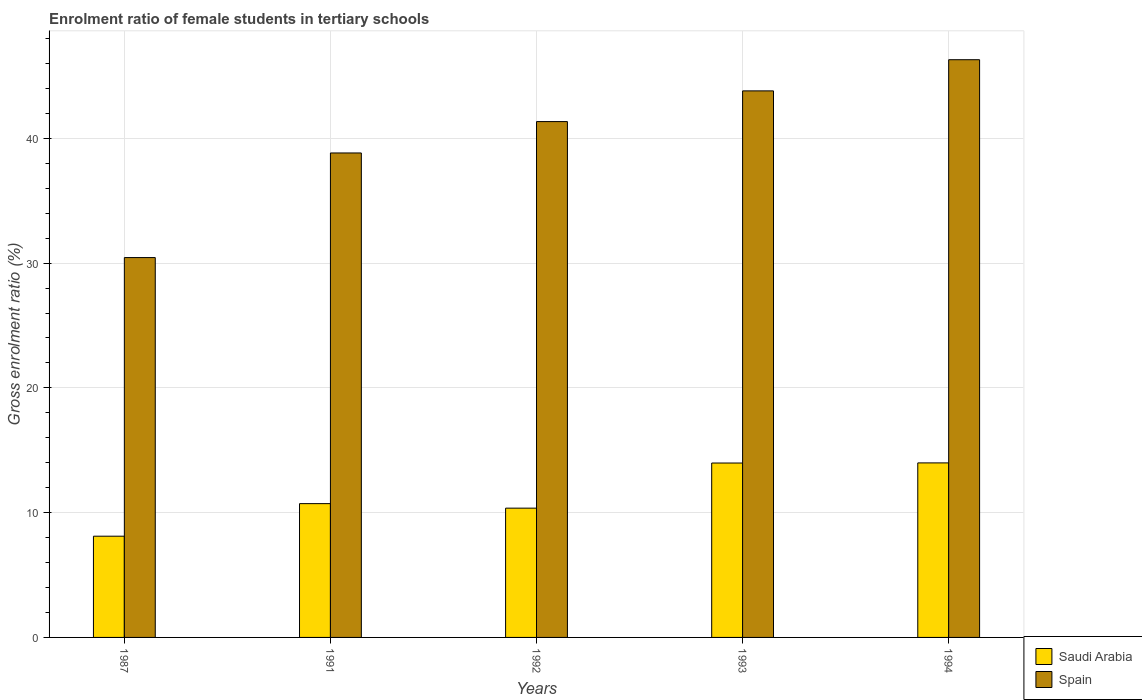How many different coloured bars are there?
Offer a very short reply. 2. How many groups of bars are there?
Give a very brief answer. 5. How many bars are there on the 1st tick from the right?
Your answer should be compact. 2. What is the label of the 3rd group of bars from the left?
Offer a terse response. 1992. In how many cases, is the number of bars for a given year not equal to the number of legend labels?
Your response must be concise. 0. What is the enrolment ratio of female students in tertiary schools in Spain in 1993?
Your answer should be compact. 43.8. Across all years, what is the maximum enrolment ratio of female students in tertiary schools in Spain?
Your response must be concise. 46.3. Across all years, what is the minimum enrolment ratio of female students in tertiary schools in Saudi Arabia?
Your response must be concise. 8.11. In which year was the enrolment ratio of female students in tertiary schools in Spain maximum?
Your answer should be very brief. 1994. What is the total enrolment ratio of female students in tertiary schools in Spain in the graph?
Give a very brief answer. 200.71. What is the difference between the enrolment ratio of female students in tertiary schools in Saudi Arabia in 1992 and that in 1993?
Offer a terse response. -3.62. What is the difference between the enrolment ratio of female students in tertiary schools in Spain in 1991 and the enrolment ratio of female students in tertiary schools in Saudi Arabia in 1994?
Provide a short and direct response. 24.84. What is the average enrolment ratio of female students in tertiary schools in Spain per year?
Keep it short and to the point. 40.14. In the year 1993, what is the difference between the enrolment ratio of female students in tertiary schools in Spain and enrolment ratio of female students in tertiary schools in Saudi Arabia?
Your answer should be compact. 29.83. In how many years, is the enrolment ratio of female students in tertiary schools in Saudi Arabia greater than 28 %?
Make the answer very short. 0. What is the ratio of the enrolment ratio of female students in tertiary schools in Saudi Arabia in 1987 to that in 1994?
Your response must be concise. 0.58. Is the difference between the enrolment ratio of female students in tertiary schools in Spain in 1993 and 1994 greater than the difference between the enrolment ratio of female students in tertiary schools in Saudi Arabia in 1993 and 1994?
Make the answer very short. No. What is the difference between the highest and the second highest enrolment ratio of female students in tertiary schools in Saudi Arabia?
Your answer should be very brief. 0.01. What is the difference between the highest and the lowest enrolment ratio of female students in tertiary schools in Spain?
Ensure brevity in your answer.  15.86. In how many years, is the enrolment ratio of female students in tertiary schools in Saudi Arabia greater than the average enrolment ratio of female students in tertiary schools in Saudi Arabia taken over all years?
Offer a terse response. 2. Is the sum of the enrolment ratio of female students in tertiary schools in Saudi Arabia in 1987 and 1994 greater than the maximum enrolment ratio of female students in tertiary schools in Spain across all years?
Your answer should be compact. No. What does the 1st bar from the left in 1992 represents?
Make the answer very short. Saudi Arabia. What does the 2nd bar from the right in 1994 represents?
Your response must be concise. Saudi Arabia. How many years are there in the graph?
Your answer should be very brief. 5. What is the difference between two consecutive major ticks on the Y-axis?
Give a very brief answer. 10. Are the values on the major ticks of Y-axis written in scientific E-notation?
Provide a short and direct response. No. What is the title of the graph?
Your response must be concise. Enrolment ratio of female students in tertiary schools. What is the label or title of the Y-axis?
Keep it short and to the point. Gross enrolment ratio (%). What is the Gross enrolment ratio (%) of Saudi Arabia in 1987?
Offer a very short reply. 8.11. What is the Gross enrolment ratio (%) in Spain in 1987?
Provide a succinct answer. 30.44. What is the Gross enrolment ratio (%) of Saudi Arabia in 1991?
Offer a terse response. 10.72. What is the Gross enrolment ratio (%) in Spain in 1991?
Provide a succinct answer. 38.83. What is the Gross enrolment ratio (%) of Saudi Arabia in 1992?
Keep it short and to the point. 10.36. What is the Gross enrolment ratio (%) in Spain in 1992?
Your response must be concise. 41.34. What is the Gross enrolment ratio (%) in Saudi Arabia in 1993?
Keep it short and to the point. 13.98. What is the Gross enrolment ratio (%) in Spain in 1993?
Offer a terse response. 43.8. What is the Gross enrolment ratio (%) in Saudi Arabia in 1994?
Your response must be concise. 13.99. What is the Gross enrolment ratio (%) of Spain in 1994?
Your answer should be compact. 46.3. Across all years, what is the maximum Gross enrolment ratio (%) in Saudi Arabia?
Your answer should be very brief. 13.99. Across all years, what is the maximum Gross enrolment ratio (%) in Spain?
Offer a very short reply. 46.3. Across all years, what is the minimum Gross enrolment ratio (%) of Saudi Arabia?
Your answer should be compact. 8.11. Across all years, what is the minimum Gross enrolment ratio (%) of Spain?
Your answer should be compact. 30.44. What is the total Gross enrolment ratio (%) of Saudi Arabia in the graph?
Your answer should be very brief. 57.16. What is the total Gross enrolment ratio (%) in Spain in the graph?
Offer a very short reply. 200.71. What is the difference between the Gross enrolment ratio (%) in Saudi Arabia in 1987 and that in 1991?
Make the answer very short. -2.61. What is the difference between the Gross enrolment ratio (%) of Spain in 1987 and that in 1991?
Your answer should be very brief. -8.38. What is the difference between the Gross enrolment ratio (%) of Saudi Arabia in 1987 and that in 1992?
Give a very brief answer. -2.25. What is the difference between the Gross enrolment ratio (%) in Spain in 1987 and that in 1992?
Ensure brevity in your answer.  -10.9. What is the difference between the Gross enrolment ratio (%) in Saudi Arabia in 1987 and that in 1993?
Offer a very short reply. -5.87. What is the difference between the Gross enrolment ratio (%) of Spain in 1987 and that in 1993?
Keep it short and to the point. -13.36. What is the difference between the Gross enrolment ratio (%) in Saudi Arabia in 1987 and that in 1994?
Your answer should be compact. -5.87. What is the difference between the Gross enrolment ratio (%) in Spain in 1987 and that in 1994?
Give a very brief answer. -15.86. What is the difference between the Gross enrolment ratio (%) in Saudi Arabia in 1991 and that in 1992?
Offer a very short reply. 0.36. What is the difference between the Gross enrolment ratio (%) of Spain in 1991 and that in 1992?
Keep it short and to the point. -2.51. What is the difference between the Gross enrolment ratio (%) in Saudi Arabia in 1991 and that in 1993?
Your response must be concise. -3.25. What is the difference between the Gross enrolment ratio (%) of Spain in 1991 and that in 1993?
Make the answer very short. -4.98. What is the difference between the Gross enrolment ratio (%) in Saudi Arabia in 1991 and that in 1994?
Make the answer very short. -3.26. What is the difference between the Gross enrolment ratio (%) in Spain in 1991 and that in 1994?
Ensure brevity in your answer.  -7.47. What is the difference between the Gross enrolment ratio (%) of Saudi Arabia in 1992 and that in 1993?
Give a very brief answer. -3.62. What is the difference between the Gross enrolment ratio (%) in Spain in 1992 and that in 1993?
Keep it short and to the point. -2.46. What is the difference between the Gross enrolment ratio (%) in Saudi Arabia in 1992 and that in 1994?
Give a very brief answer. -3.63. What is the difference between the Gross enrolment ratio (%) in Spain in 1992 and that in 1994?
Make the answer very short. -4.96. What is the difference between the Gross enrolment ratio (%) of Saudi Arabia in 1993 and that in 1994?
Make the answer very short. -0.01. What is the difference between the Gross enrolment ratio (%) in Spain in 1993 and that in 1994?
Provide a short and direct response. -2.5. What is the difference between the Gross enrolment ratio (%) of Saudi Arabia in 1987 and the Gross enrolment ratio (%) of Spain in 1991?
Your answer should be very brief. -30.71. What is the difference between the Gross enrolment ratio (%) in Saudi Arabia in 1987 and the Gross enrolment ratio (%) in Spain in 1992?
Provide a short and direct response. -33.23. What is the difference between the Gross enrolment ratio (%) of Saudi Arabia in 1987 and the Gross enrolment ratio (%) of Spain in 1993?
Offer a terse response. -35.69. What is the difference between the Gross enrolment ratio (%) in Saudi Arabia in 1987 and the Gross enrolment ratio (%) in Spain in 1994?
Your answer should be compact. -38.19. What is the difference between the Gross enrolment ratio (%) of Saudi Arabia in 1991 and the Gross enrolment ratio (%) of Spain in 1992?
Your response must be concise. -30.62. What is the difference between the Gross enrolment ratio (%) in Saudi Arabia in 1991 and the Gross enrolment ratio (%) in Spain in 1993?
Your response must be concise. -33.08. What is the difference between the Gross enrolment ratio (%) in Saudi Arabia in 1991 and the Gross enrolment ratio (%) in Spain in 1994?
Your answer should be very brief. -35.58. What is the difference between the Gross enrolment ratio (%) of Saudi Arabia in 1992 and the Gross enrolment ratio (%) of Spain in 1993?
Offer a terse response. -33.44. What is the difference between the Gross enrolment ratio (%) of Saudi Arabia in 1992 and the Gross enrolment ratio (%) of Spain in 1994?
Provide a succinct answer. -35.94. What is the difference between the Gross enrolment ratio (%) of Saudi Arabia in 1993 and the Gross enrolment ratio (%) of Spain in 1994?
Your response must be concise. -32.32. What is the average Gross enrolment ratio (%) of Saudi Arabia per year?
Your answer should be compact. 11.43. What is the average Gross enrolment ratio (%) of Spain per year?
Your response must be concise. 40.14. In the year 1987, what is the difference between the Gross enrolment ratio (%) of Saudi Arabia and Gross enrolment ratio (%) of Spain?
Ensure brevity in your answer.  -22.33. In the year 1991, what is the difference between the Gross enrolment ratio (%) in Saudi Arabia and Gross enrolment ratio (%) in Spain?
Make the answer very short. -28.1. In the year 1992, what is the difference between the Gross enrolment ratio (%) in Saudi Arabia and Gross enrolment ratio (%) in Spain?
Offer a terse response. -30.98. In the year 1993, what is the difference between the Gross enrolment ratio (%) in Saudi Arabia and Gross enrolment ratio (%) in Spain?
Your response must be concise. -29.83. In the year 1994, what is the difference between the Gross enrolment ratio (%) of Saudi Arabia and Gross enrolment ratio (%) of Spain?
Your answer should be compact. -32.31. What is the ratio of the Gross enrolment ratio (%) in Saudi Arabia in 1987 to that in 1991?
Your answer should be compact. 0.76. What is the ratio of the Gross enrolment ratio (%) of Spain in 1987 to that in 1991?
Offer a terse response. 0.78. What is the ratio of the Gross enrolment ratio (%) in Saudi Arabia in 1987 to that in 1992?
Make the answer very short. 0.78. What is the ratio of the Gross enrolment ratio (%) of Spain in 1987 to that in 1992?
Offer a very short reply. 0.74. What is the ratio of the Gross enrolment ratio (%) of Saudi Arabia in 1987 to that in 1993?
Your answer should be compact. 0.58. What is the ratio of the Gross enrolment ratio (%) in Spain in 1987 to that in 1993?
Your answer should be very brief. 0.69. What is the ratio of the Gross enrolment ratio (%) of Saudi Arabia in 1987 to that in 1994?
Offer a very short reply. 0.58. What is the ratio of the Gross enrolment ratio (%) of Spain in 1987 to that in 1994?
Your answer should be compact. 0.66. What is the ratio of the Gross enrolment ratio (%) in Saudi Arabia in 1991 to that in 1992?
Offer a very short reply. 1.03. What is the ratio of the Gross enrolment ratio (%) of Spain in 1991 to that in 1992?
Ensure brevity in your answer.  0.94. What is the ratio of the Gross enrolment ratio (%) of Saudi Arabia in 1991 to that in 1993?
Make the answer very short. 0.77. What is the ratio of the Gross enrolment ratio (%) of Spain in 1991 to that in 1993?
Offer a very short reply. 0.89. What is the ratio of the Gross enrolment ratio (%) of Saudi Arabia in 1991 to that in 1994?
Your answer should be very brief. 0.77. What is the ratio of the Gross enrolment ratio (%) in Spain in 1991 to that in 1994?
Ensure brevity in your answer.  0.84. What is the ratio of the Gross enrolment ratio (%) of Saudi Arabia in 1992 to that in 1993?
Ensure brevity in your answer.  0.74. What is the ratio of the Gross enrolment ratio (%) of Spain in 1992 to that in 1993?
Provide a succinct answer. 0.94. What is the ratio of the Gross enrolment ratio (%) in Saudi Arabia in 1992 to that in 1994?
Offer a terse response. 0.74. What is the ratio of the Gross enrolment ratio (%) of Spain in 1992 to that in 1994?
Keep it short and to the point. 0.89. What is the ratio of the Gross enrolment ratio (%) of Spain in 1993 to that in 1994?
Your answer should be very brief. 0.95. What is the difference between the highest and the second highest Gross enrolment ratio (%) of Saudi Arabia?
Give a very brief answer. 0.01. What is the difference between the highest and the second highest Gross enrolment ratio (%) of Spain?
Offer a terse response. 2.5. What is the difference between the highest and the lowest Gross enrolment ratio (%) of Saudi Arabia?
Your answer should be very brief. 5.87. What is the difference between the highest and the lowest Gross enrolment ratio (%) of Spain?
Your answer should be compact. 15.86. 